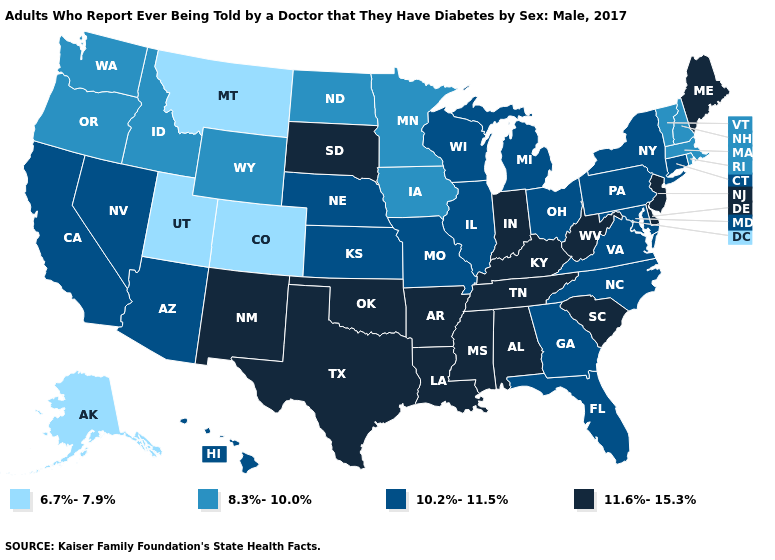Does Indiana have the highest value in the MidWest?
Concise answer only. Yes. Among the states that border Rhode Island , which have the lowest value?
Be succinct. Massachusetts. What is the highest value in the MidWest ?
Write a very short answer. 11.6%-15.3%. Among the states that border Maryland , does Delaware have the lowest value?
Keep it brief. No. What is the highest value in the USA?
Short answer required. 11.6%-15.3%. Among the states that border Iowa , does Nebraska have the lowest value?
Write a very short answer. No. Which states have the highest value in the USA?
Keep it brief. Alabama, Arkansas, Delaware, Indiana, Kentucky, Louisiana, Maine, Mississippi, New Jersey, New Mexico, Oklahoma, South Carolina, South Dakota, Tennessee, Texas, West Virginia. What is the value of Pennsylvania?
Short answer required. 10.2%-11.5%. Does Indiana have the highest value in the MidWest?
Concise answer only. Yes. What is the value of Colorado?
Quick response, please. 6.7%-7.9%. What is the value of South Carolina?
Write a very short answer. 11.6%-15.3%. Does Alabama have the highest value in the USA?
Concise answer only. Yes. Name the states that have a value in the range 11.6%-15.3%?
Answer briefly. Alabama, Arkansas, Delaware, Indiana, Kentucky, Louisiana, Maine, Mississippi, New Jersey, New Mexico, Oklahoma, South Carolina, South Dakota, Tennessee, Texas, West Virginia. Among the states that border Alabama , does Mississippi have the lowest value?
Be succinct. No. 